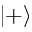Convert formula to latex. <formula><loc_0><loc_0><loc_500><loc_500>| + \rangle</formula> 